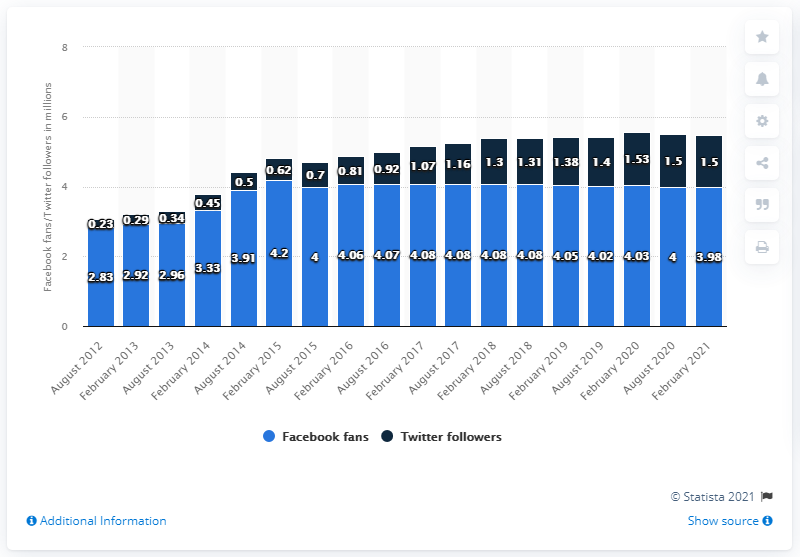Point out several critical features in this image. As of February 2021, the New Orleans Saints football team had 3.98 million Facebook followers. The graph considers August 2013 and February 2013 as months for its representation. The followers of the company have been 4 million for the periods of August 2015 and August 2020. 